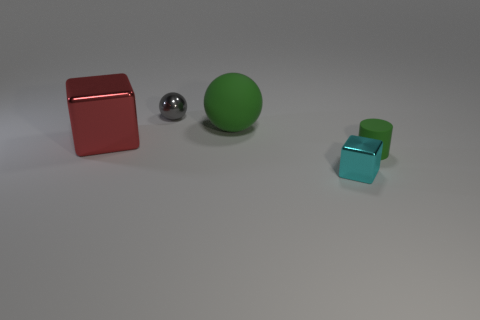Can you tell me about the sizes and shapes of the objects in the image? Certainly! The image shows a collection of five objects with varying sizes and shapes. On the left, there's a large, red metal cube with a reflective surface. Next to it is a medium-sized shiny metal sphere, and a small green rubber ball with a matte finish. On the right, are two cubes – the first is a larger blue transparent cube, and closer to the foreground is a smaller cube of the same color and transparency. The diversity in their sizes and shapes creates an interesting visual contrast. 